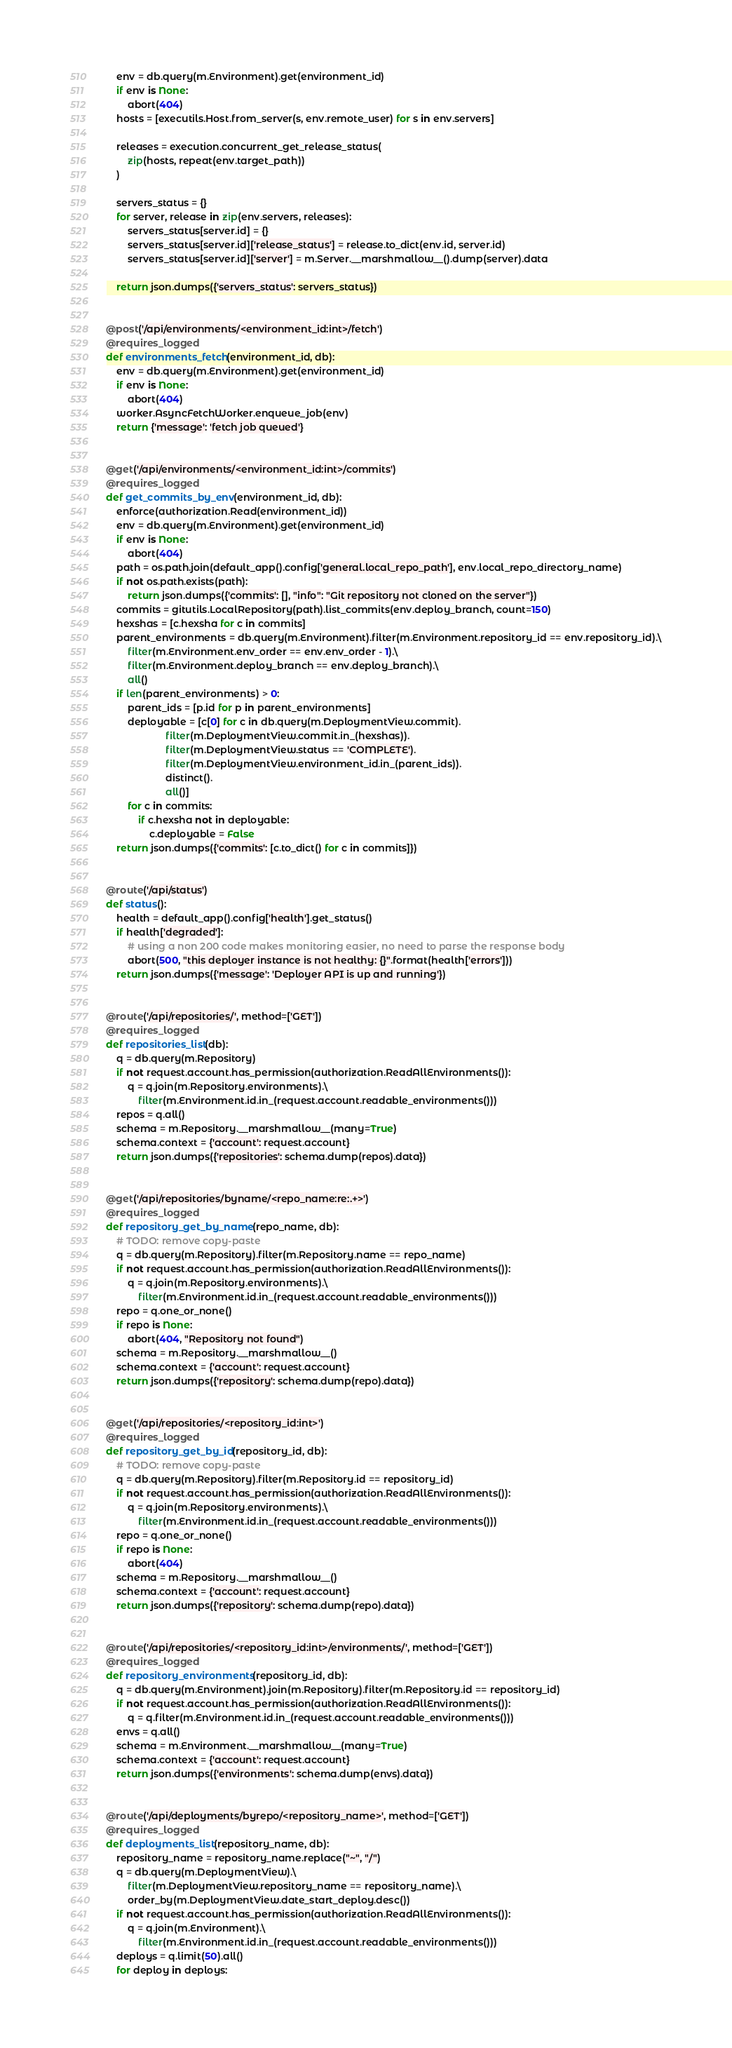<code> <loc_0><loc_0><loc_500><loc_500><_Python_>    env = db.query(m.Environment).get(environment_id)
    if env is None:
        abort(404)
    hosts = [executils.Host.from_server(s, env.remote_user) for s in env.servers]

    releases = execution.concurrent_get_release_status(
        zip(hosts, repeat(env.target_path))
    )

    servers_status = {}
    for server, release in zip(env.servers, releases):
        servers_status[server.id] = {}
        servers_status[server.id]['release_status'] = release.to_dict(env.id, server.id)
        servers_status[server.id]['server'] = m.Server.__marshmallow__().dump(server).data

    return json.dumps({'servers_status': servers_status})


@post('/api/environments/<environment_id:int>/fetch')
@requires_logged
def environments_fetch(environment_id, db):
    env = db.query(m.Environment).get(environment_id)
    if env is None:
        abort(404)
    worker.AsyncFetchWorker.enqueue_job(env)
    return {'message': 'fetch job queued'}


@get('/api/environments/<environment_id:int>/commits')
@requires_logged
def get_commits_by_env(environment_id, db):
    enforce(authorization.Read(environment_id))
    env = db.query(m.Environment).get(environment_id)
    if env is None:
        abort(404)
    path = os.path.join(default_app().config['general.local_repo_path'], env.local_repo_directory_name)
    if not os.path.exists(path):
        return json.dumps({'commits': [], "info": "Git repository not cloned on the server"})
    commits = gitutils.LocalRepository(path).list_commits(env.deploy_branch, count=150)
    hexshas = [c.hexsha for c in commits]
    parent_environments = db.query(m.Environment).filter(m.Environment.repository_id == env.repository_id).\
        filter(m.Environment.env_order == env.env_order - 1).\
        filter(m.Environment.deploy_branch == env.deploy_branch).\
        all()
    if len(parent_environments) > 0:
        parent_ids = [p.id for p in parent_environments]
        deployable = [c[0] for c in db.query(m.DeploymentView.commit).
                      filter(m.DeploymentView.commit.in_(hexshas)).
                      filter(m.DeploymentView.status == 'COMPLETE').
                      filter(m.DeploymentView.environment_id.in_(parent_ids)).
                      distinct().
                      all()]
        for c in commits:
            if c.hexsha not in deployable:
                c.deployable = False
    return json.dumps({'commits': [c.to_dict() for c in commits]})


@route('/api/status')
def status():
    health = default_app().config['health'].get_status()
    if health['degraded']:
        # using a non 200 code makes monitoring easier, no need to parse the response body
        abort(500, "this deployer instance is not healthy: {}".format(health['errors']))
    return json.dumps({'message': 'Deployer API is up and running'})


@route('/api/repositories/', method=['GET'])
@requires_logged
def repositories_list(db):
    q = db.query(m.Repository)
    if not request.account.has_permission(authorization.ReadAllEnvironments()):
        q = q.join(m.Repository.environments).\
            filter(m.Environment.id.in_(request.account.readable_environments()))
    repos = q.all()
    schema = m.Repository.__marshmallow__(many=True)
    schema.context = {'account': request.account}
    return json.dumps({'repositories': schema.dump(repos).data})


@get('/api/repositories/byname/<repo_name:re:.+>')
@requires_logged
def repository_get_by_name(repo_name, db):
    # TODO: remove copy-paste
    q = db.query(m.Repository).filter(m.Repository.name == repo_name)
    if not request.account.has_permission(authorization.ReadAllEnvironments()):
        q = q.join(m.Repository.environments).\
            filter(m.Environment.id.in_(request.account.readable_environments()))
    repo = q.one_or_none()
    if repo is None:
        abort(404, "Repository not found")
    schema = m.Repository.__marshmallow__()
    schema.context = {'account': request.account}
    return json.dumps({'repository': schema.dump(repo).data})


@get('/api/repositories/<repository_id:int>')
@requires_logged
def repository_get_by_id(repository_id, db):
    # TODO: remove copy-paste
    q = db.query(m.Repository).filter(m.Repository.id == repository_id)
    if not request.account.has_permission(authorization.ReadAllEnvironments()):
        q = q.join(m.Repository.environments).\
            filter(m.Environment.id.in_(request.account.readable_environments()))
    repo = q.one_or_none()
    if repo is None:
        abort(404)
    schema = m.Repository.__marshmallow__()
    schema.context = {'account': request.account}
    return json.dumps({'repository': schema.dump(repo).data})


@route('/api/repositories/<repository_id:int>/environments/', method=['GET'])
@requires_logged
def repository_environments(repository_id, db):
    q = db.query(m.Environment).join(m.Repository).filter(m.Repository.id == repository_id)
    if not request.account.has_permission(authorization.ReadAllEnvironments()):
        q = q.filter(m.Environment.id.in_(request.account.readable_environments()))
    envs = q.all()
    schema = m.Environment.__marshmallow__(many=True)
    schema.context = {'account': request.account}
    return json.dumps({'environments': schema.dump(envs).data})


@route('/api/deployments/byrepo/<repository_name>', method=['GET'])
@requires_logged
def deployments_list(repository_name, db):
    repository_name = repository_name.replace("~", "/")
    q = db.query(m.DeploymentView).\
        filter(m.DeploymentView.repository_name == repository_name).\
        order_by(m.DeploymentView.date_start_deploy.desc())
    if not request.account.has_permission(authorization.ReadAllEnvironments()):
        q = q.join(m.Environment).\
            filter(m.Environment.id.in_(request.account.readable_environments()))
    deploys = q.limit(50).all()
    for deploy in deploys:</code> 